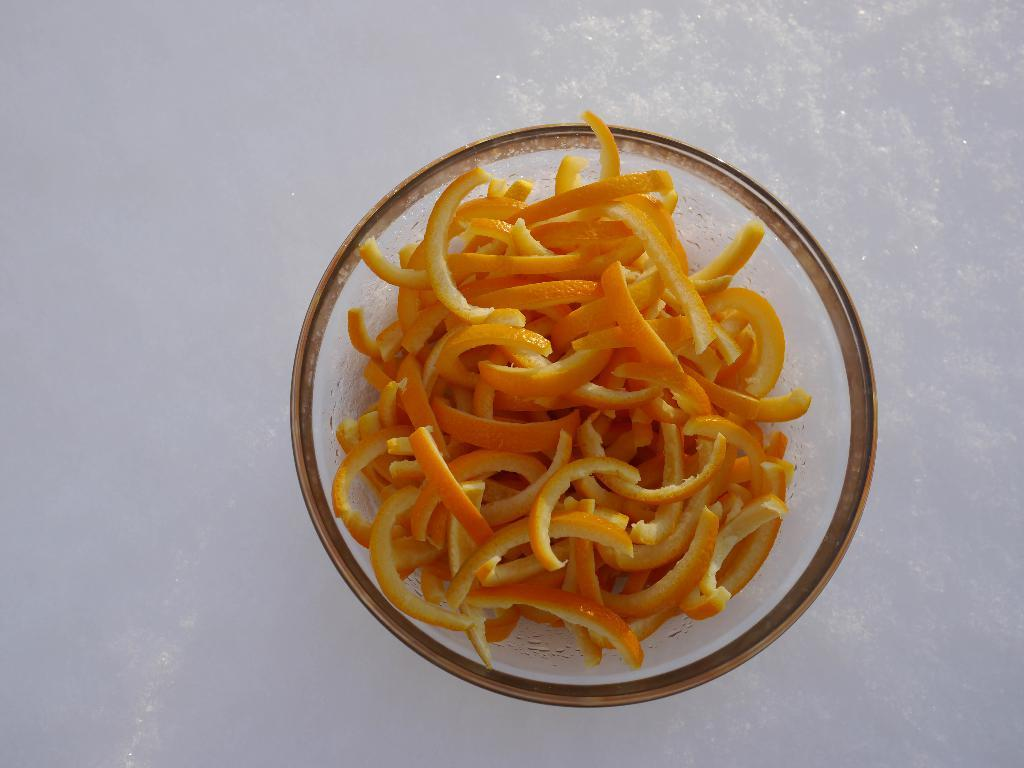What is in the bowl that is visible in the image? There are orange peel slices in the bowl. Where is the bowl located in the image? The bowl is placed on a white surface. What might be the purpose of the orange peel slices in the image? The orange peel slices could be used for various purposes, such as cooking or garnishing. Can you see a glove being used to teach a lesson in the image? No, there is no glove or teaching activity present in the image. 